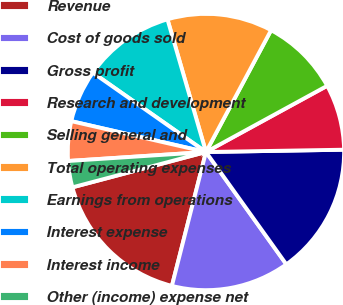Convert chart. <chart><loc_0><loc_0><loc_500><loc_500><pie_chart><fcel>Revenue<fcel>Cost of goods sold<fcel>Gross profit<fcel>Research and development<fcel>Selling general and<fcel>Total operating expenses<fcel>Earnings from operations<fcel>Interest expense<fcel>Interest income<fcel>Other (income) expense net<nl><fcel>16.92%<fcel>13.85%<fcel>15.38%<fcel>7.69%<fcel>9.23%<fcel>12.31%<fcel>10.77%<fcel>6.15%<fcel>4.62%<fcel>3.08%<nl></chart> 